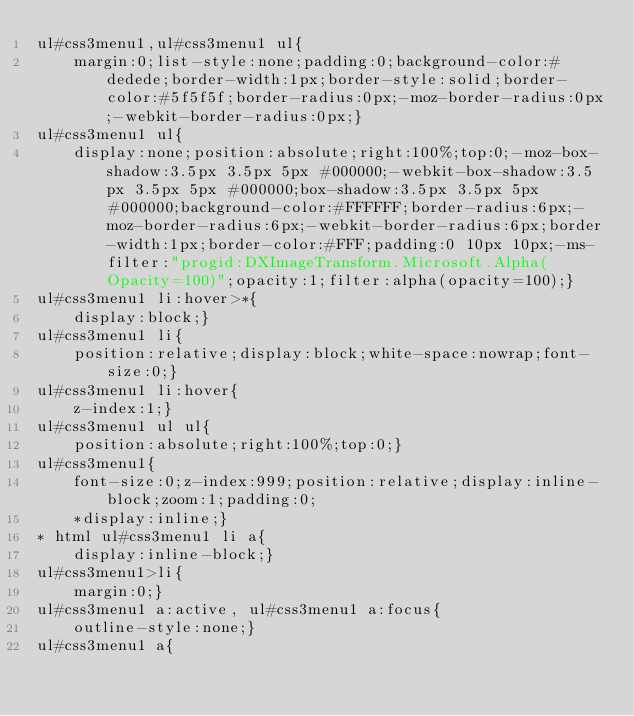<code> <loc_0><loc_0><loc_500><loc_500><_CSS_>ul#css3menu1,ul#css3menu1 ul{
	margin:0;list-style:none;padding:0;background-color:#dedede;border-width:1px;border-style:solid;border-color:#5f5f5f;border-radius:0px;-moz-border-radius:0px;-webkit-border-radius:0px;}
ul#css3menu1 ul{
	display:none;position:absolute;right:100%;top:0;-moz-box-shadow:3.5px 3.5px 5px #000000;-webkit-box-shadow:3.5px 3.5px 5px #000000;box-shadow:3.5px 3.5px 5px #000000;background-color:#FFFFFF;border-radius:6px;-moz-border-radius:6px;-webkit-border-radius:6px;border-width:1px;border-color:#FFF;padding:0 10px 10px;-ms-filter:"progid:DXImageTransform.Microsoft.Alpha(Opacity=100)";opacity:1;filter:alpha(opacity=100);}
ul#css3menu1 li:hover>*{
	display:block;}
ul#css3menu1 li{
	position:relative;display:block;white-space:nowrap;font-size:0;}
ul#css3menu1 li:hover{
	z-index:1;}
ul#css3menu1 ul ul{
	position:absolute;right:100%;top:0;}
ul#css3menu1{
	font-size:0;z-index:999;position:relative;display:inline-block;zoom:1;padding:0;
	*display:inline;}
* html ul#css3menu1 li a{
	display:inline-block;}
ul#css3menu1>li{
	margin:0;}
ul#css3menu1 a:active, ul#css3menu1 a:focus{
	outline-style:none;}
ul#css3menu1 a{ </code> 